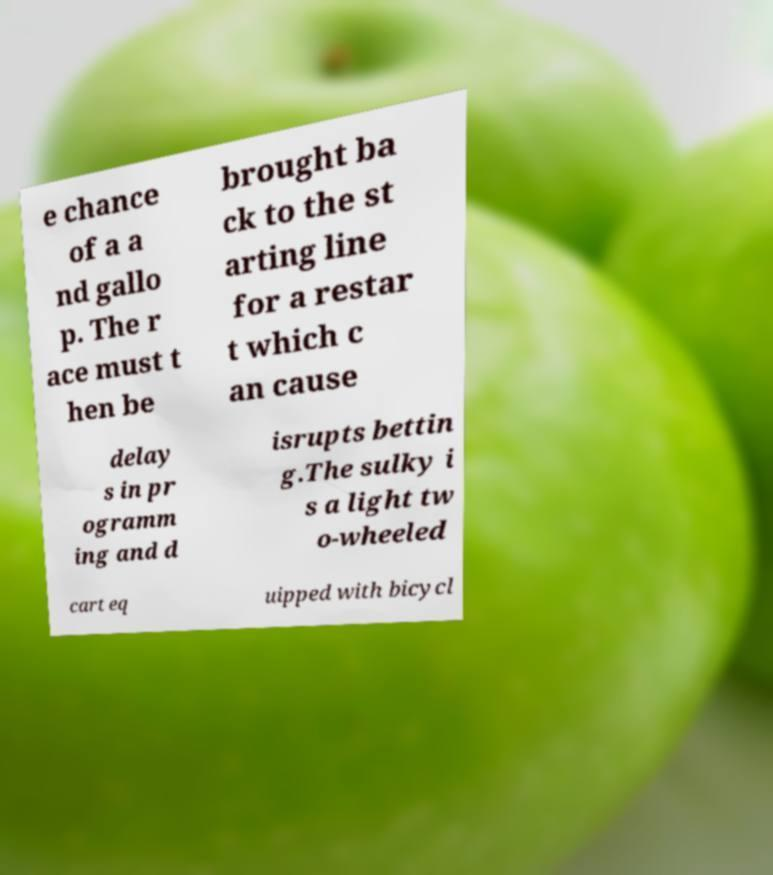Can you accurately transcribe the text from the provided image for me? e chance of a a nd gallo p. The r ace must t hen be brought ba ck to the st arting line for a restar t which c an cause delay s in pr ogramm ing and d isrupts bettin g.The sulky i s a light tw o-wheeled cart eq uipped with bicycl 